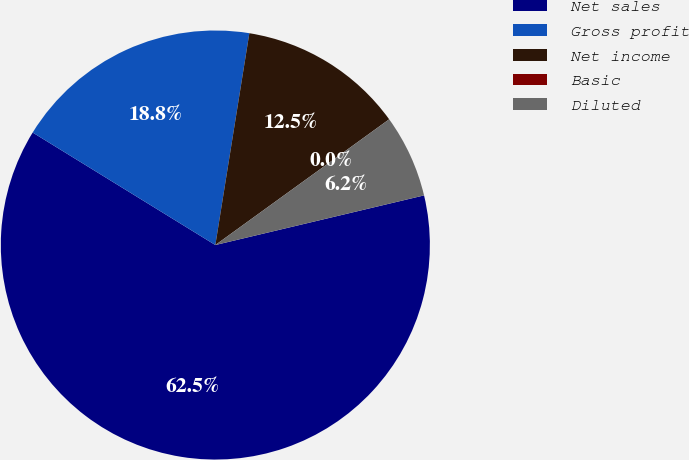<chart> <loc_0><loc_0><loc_500><loc_500><pie_chart><fcel>Net sales<fcel>Gross profit<fcel>Net income<fcel>Basic<fcel>Diluted<nl><fcel>62.5%<fcel>18.75%<fcel>12.5%<fcel>0.0%<fcel>6.25%<nl></chart> 